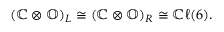Convert formula to latex. <formula><loc_0><loc_0><loc_500><loc_500>\begin{array} { r } { ( \mathbb { C } \otimes \mathbb { O } ) _ { L } \cong ( \mathbb { C } \otimes \mathbb { O } ) _ { R } \cong \mathbb { C } \ell ( 6 ) . } \end{array}</formula> 